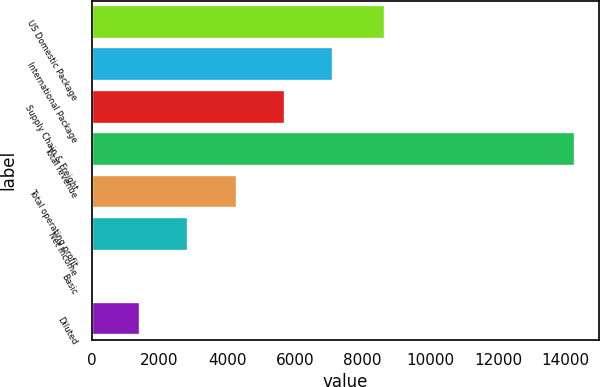Convert chart to OTSL. <chart><loc_0><loc_0><loc_500><loc_500><bar_chart><fcel>US Domestic Package<fcel>International Package<fcel>Supply Chain & Freight<fcel>Total revenue<fcel>Total operating profit<fcel>Net Income<fcel>Basic<fcel>Diluted<nl><fcel>8668<fcel>7134.24<fcel>5707.49<fcel>14268<fcel>4280.74<fcel>2853.99<fcel>0.49<fcel>1427.24<nl></chart> 